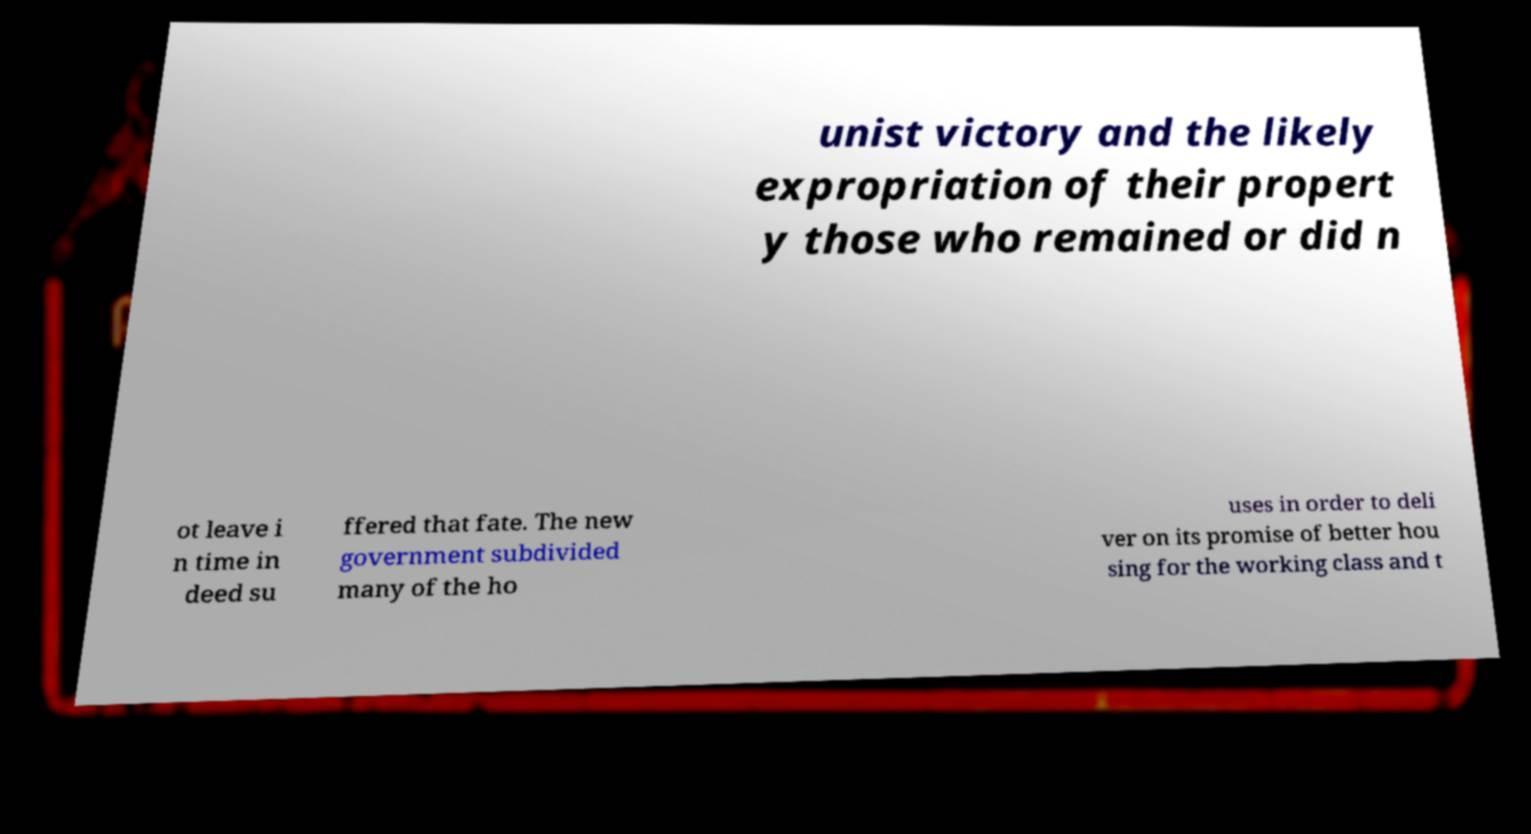Could you assist in decoding the text presented in this image and type it out clearly? unist victory and the likely expropriation of their propert y those who remained or did n ot leave i n time in deed su ffered that fate. The new government subdivided many of the ho uses in order to deli ver on its promise of better hou sing for the working class and t 